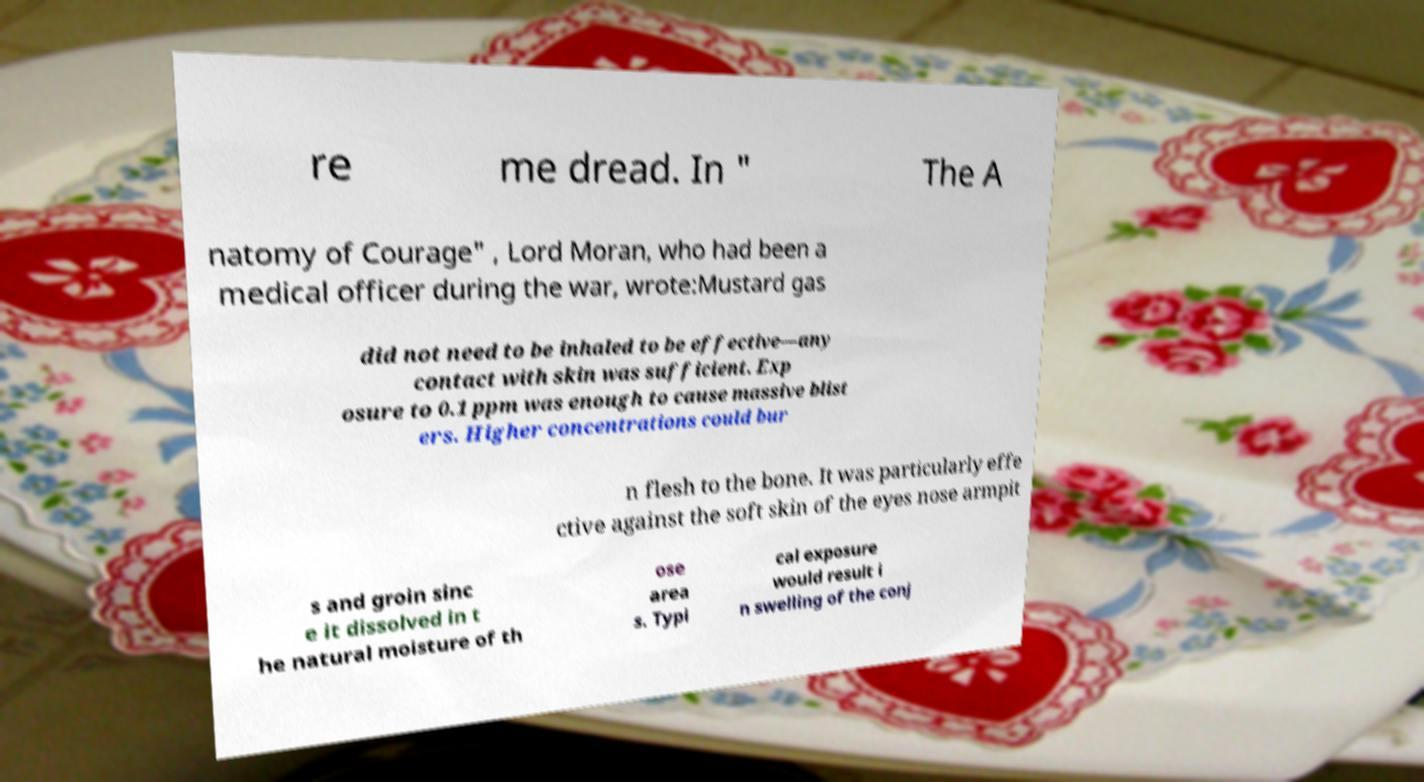For documentation purposes, I need the text within this image transcribed. Could you provide that? re me dread. In " The A natomy of Courage" , Lord Moran, who had been a medical officer during the war, wrote:Mustard gas did not need to be inhaled to be effective—any contact with skin was sufficient. Exp osure to 0.1 ppm was enough to cause massive blist ers. Higher concentrations could bur n flesh to the bone. It was particularly effe ctive against the soft skin of the eyes nose armpit s and groin sinc e it dissolved in t he natural moisture of th ose area s. Typi cal exposure would result i n swelling of the conj 